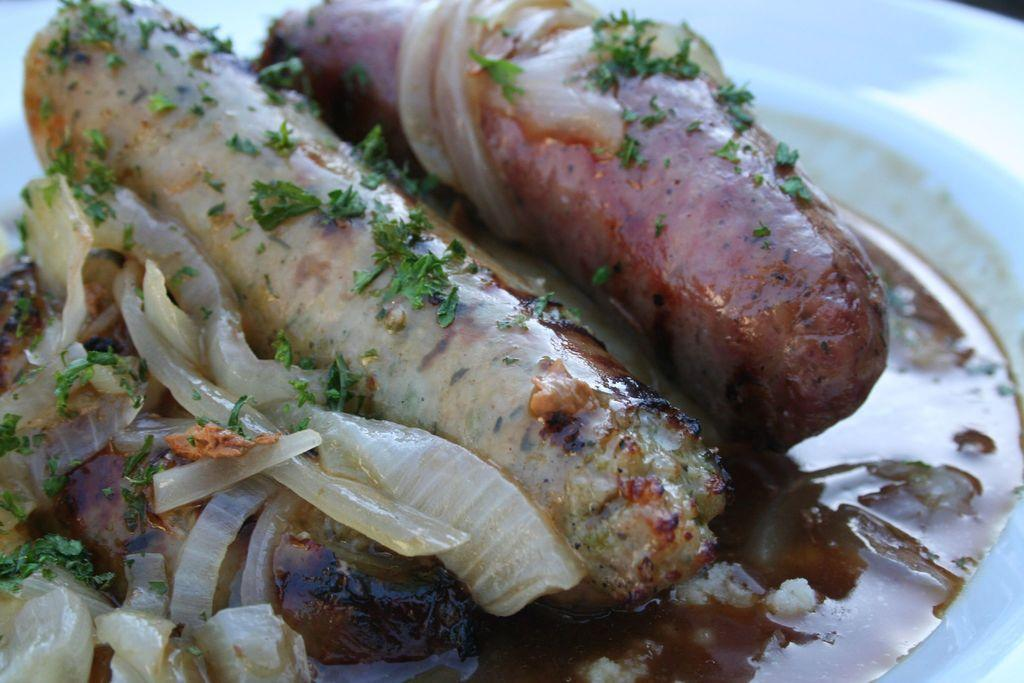What is on the plate that is visible in the image? There is a plate of food in the image. What type of food can be seen on the plate? The plate of food contains sausages. How many legs can be seen on the sack in the image? There is no sack present in the image, so it is not possible to determine the number of legs on a sack. 